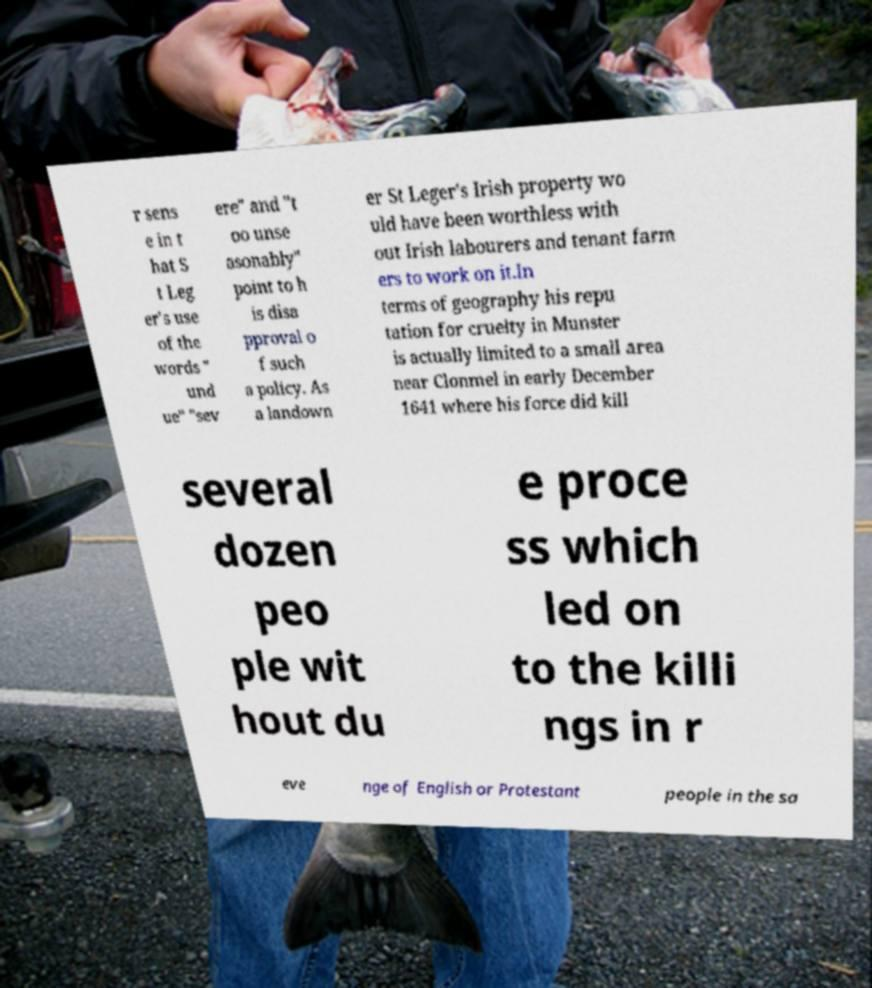Please read and relay the text visible in this image. What does it say? r sens e in t hat S t Leg er's use of the words " und ue" "sev ere" and "t oo unse asonably" point to h is disa pproval o f such a policy. As a landown er St Leger's Irish property wo uld have been worthless with out Irish labourers and tenant farm ers to work on it.In terms of geography his repu tation for cruelty in Munster is actually limited to a small area near Clonmel in early December 1641 where his force did kill several dozen peo ple wit hout du e proce ss which led on to the killi ngs in r eve nge of English or Protestant people in the sa 